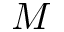<formula> <loc_0><loc_0><loc_500><loc_500>M</formula> 